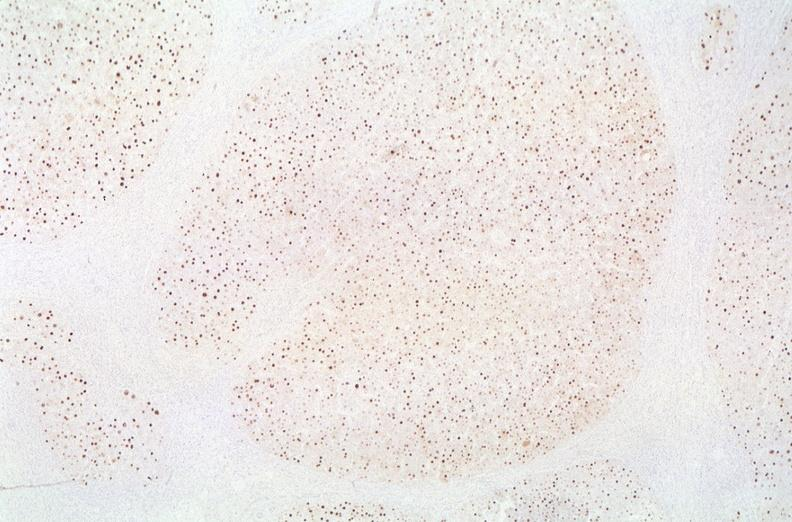what does this image show?
Answer the question using a single word or phrase. Hepatitis b virus 